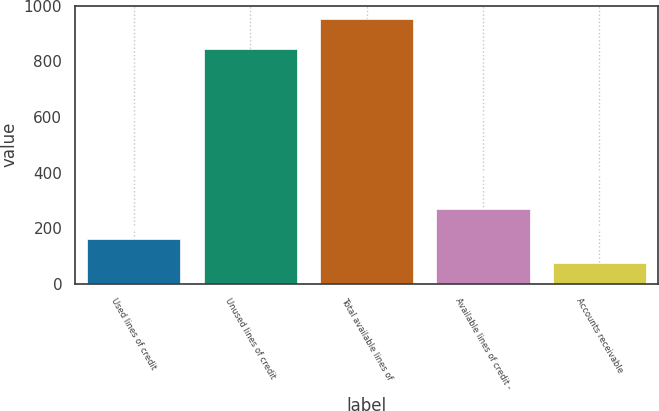<chart> <loc_0><loc_0><loc_500><loc_500><bar_chart><fcel>Used lines of credit<fcel>Unused lines of credit<fcel>Total available lines of<fcel>Available lines of credit -<fcel>Accounts receivable<nl><fcel>161.94<fcel>846.3<fcel>953.4<fcel>267.3<fcel>74<nl></chart> 